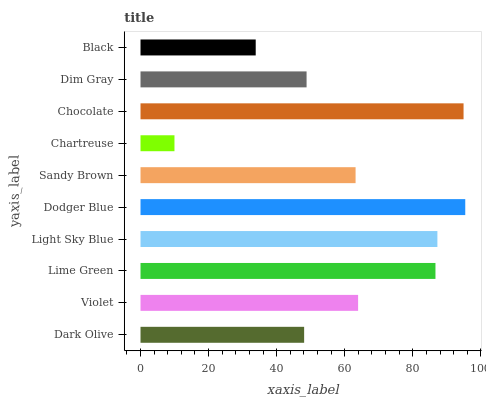Is Chartreuse the minimum?
Answer yes or no. Yes. Is Dodger Blue the maximum?
Answer yes or no. Yes. Is Violet the minimum?
Answer yes or no. No. Is Violet the maximum?
Answer yes or no. No. Is Violet greater than Dark Olive?
Answer yes or no. Yes. Is Dark Olive less than Violet?
Answer yes or no. Yes. Is Dark Olive greater than Violet?
Answer yes or no. No. Is Violet less than Dark Olive?
Answer yes or no. No. Is Violet the high median?
Answer yes or no. Yes. Is Sandy Brown the low median?
Answer yes or no. Yes. Is Light Sky Blue the high median?
Answer yes or no. No. Is Black the low median?
Answer yes or no. No. 